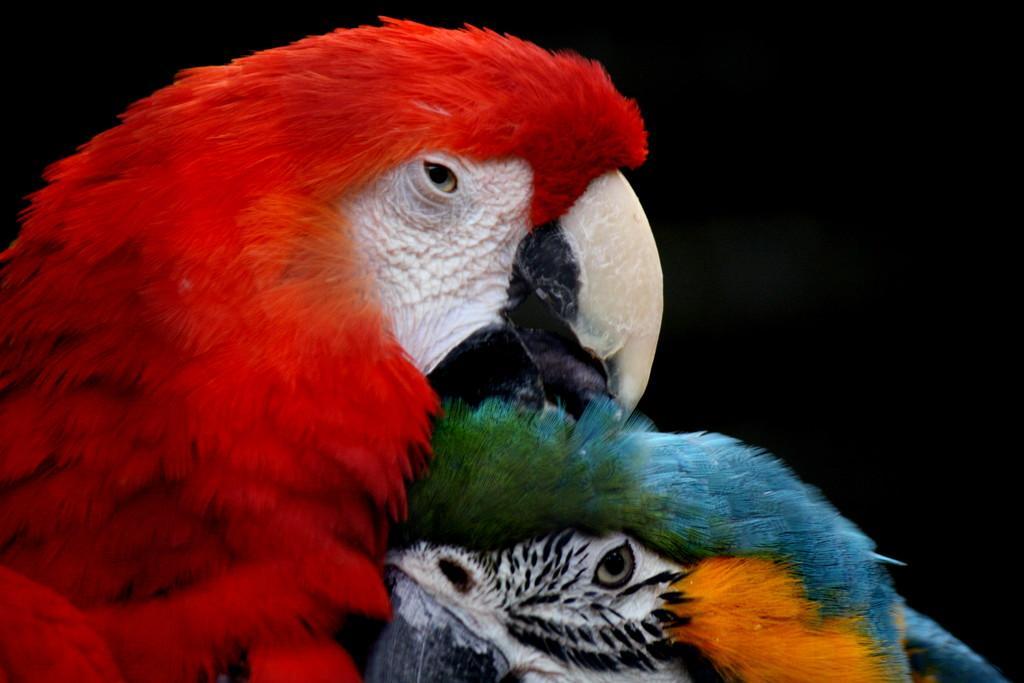Could you give a brief overview of what you see in this image? In this image I can see there is a parrot in red color on the left side. On the right side there is another bird in blue color. 